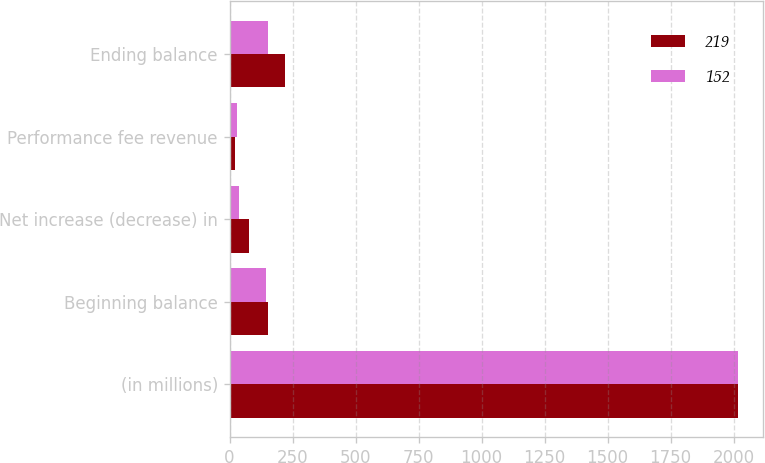<chart> <loc_0><loc_0><loc_500><loc_500><stacked_bar_chart><ecel><fcel>(in millions)<fcel>Beginning balance<fcel>Net increase (decrease) in<fcel>Performance fee revenue<fcel>Ending balance<nl><fcel>219<fcel>2017<fcel>152<fcel>75<fcel>21<fcel>219<nl><fcel>152<fcel>2016<fcel>143<fcel>37<fcel>28<fcel>152<nl></chart> 